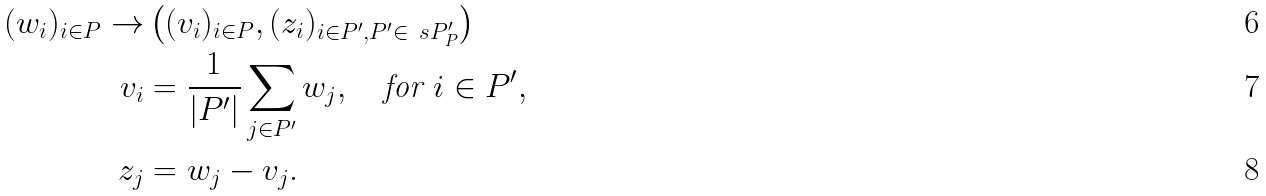<formula> <loc_0><loc_0><loc_500><loc_500>( w _ { i } ) _ { i \in P } \to & \left ( ( v _ { i } ) _ { i \in P } , ( z _ { i } ) _ { i \in P ^ { \prime } , P ^ { \prime } \in \ s P _ { P } ^ { \prime } } \right ) \\ v _ { i } & = \frac { 1 } { | P ^ { \prime } | } \sum _ { j \in P ^ { \prime } } w _ { j } , \quad \text {for $i\in P^{\prime}$} , \\ z _ { j } & = w _ { j } - v _ { j } .</formula> 